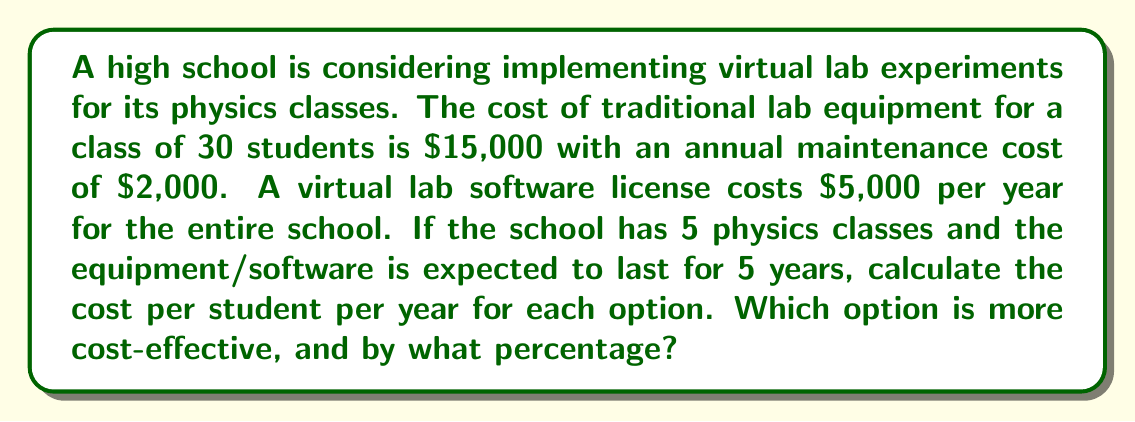Could you help me with this problem? Let's break this down step-by-step:

1. Traditional Lab Equipment:
   - Initial cost: $15,000
   - Annual maintenance: $2,000
   - Total cost over 5 years: $15,000 + (5 × $2,000) = $25,000
   
2. Virtual Lab Software:
   - Annual cost: $5,000
   - Total cost over 5 years: 5 × $5,000 = $25,000

3. Number of students:
   - 5 classes × 30 students = 150 students per year
   - Over 5 years: 150 × 5 = 750 student-years

4. Cost per student per year:
   - Traditional: $\frac{25,000}{750} = \$33.33$ per student-year
   - Virtual: $\frac{25,000}{750} = \$33.33$ per student-year

5. Cost-effectiveness comparison:
   - Both options have the same cost per student-year
   - Percentage difference: $\frac{33.33 - 33.33}{33.33} \times 100\% = 0\%$

Therefore, both options are equally cost-effective in this scenario.
Answer: Both options cost $33.33 per student-year; 0% difference 